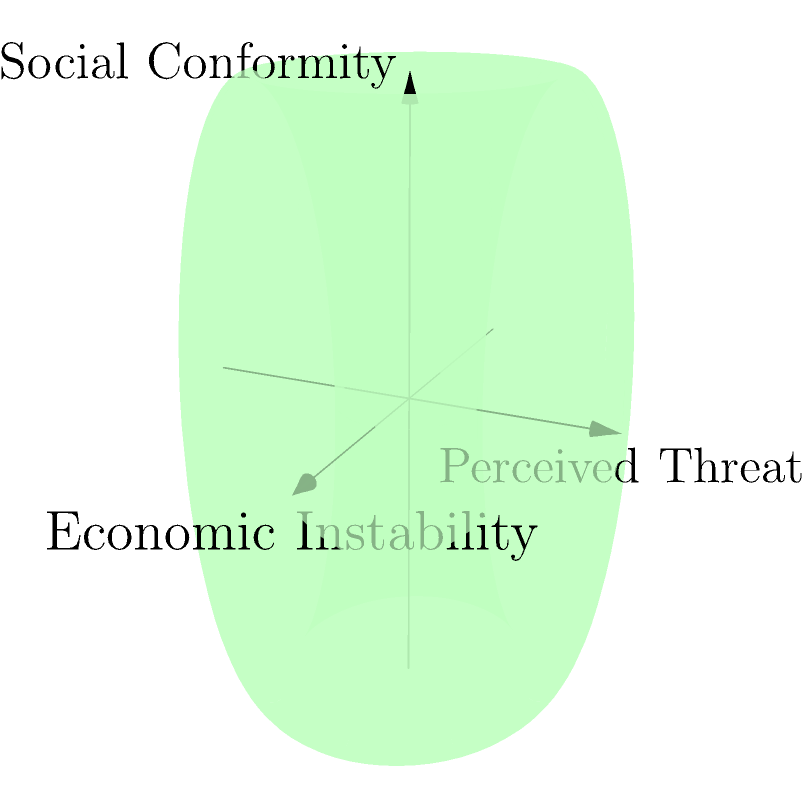Consider the three-dimensional shape shown, which represents the intersection of factors contributing to authoritarian support: economic instability (x-axis), perceived threat (y-axis), and social conformity (z-axis). The surface is defined by the function:

$$ r(\theta, \phi) = (2 + \cos\phi)(\cos\theta\hat{i} + \sin\theta\hat{j}) + \sin\phi\hat{k} $$

where $0 \leq \theta \leq 2\pi$ and $0 \leq \phi \leq 2\pi$. Calculate the volume enclosed by this surface. To calculate the volume enclosed by this surface, we need to use the triple integral in spherical coordinates:

1) The volume integral in spherical coordinates is given by:
   $$ V = \iiint r^2 \sin\phi \, dr \, d\theta \, d\phi $$

2) In our case, $r$ is a function of $\theta$ and $\phi$, so we need to cube it:
   $$ r^3 = ((2 + \cos\phi)^2 + \sin^2\phi)^{3/2} $$

3) The limits of integration are:
   $0 \leq \theta \leq 2\pi$
   $0 \leq \phi \leq 2\pi$
   $0 \leq r \leq (2 + \cos\phi)^2 + \sin^2\phi)^{1/2}$

4) Substituting into the volume integral:
   $$ V = \int_0^{2\pi} \int_0^{2\pi} \int_0^{((2 + \cos\phi)^2 + \sin^2\phi)^{1/2}} r^2 \sin\phi \, dr \, d\theta \, d\phi $$

5) Integrating with respect to $r$:
   $$ V = \frac{1}{3} \int_0^{2\pi} \int_0^{2\pi} ((2 + \cos\phi)^2 + \sin^2\phi)^{3/2} \sin\phi \, d\theta \, d\phi $$

6) Integrating with respect to $\theta$:
   $$ V = \frac{2\pi}{3} \int_0^{2\pi} ((2 + \cos\phi)^2 + \sin^2\phi)^{3/2} \sin\phi \, d\phi $$

7) This last integral doesn't have an elementary antiderivative, so we need to evaluate it numerically. Using a computer algebra system or numerical integration method, we find:

   $$ V \approx 52.6451 $$

Thus, the volume enclosed by the surface is approximately 52.6451 cubic units.
Answer: 52.6451 cubic units 